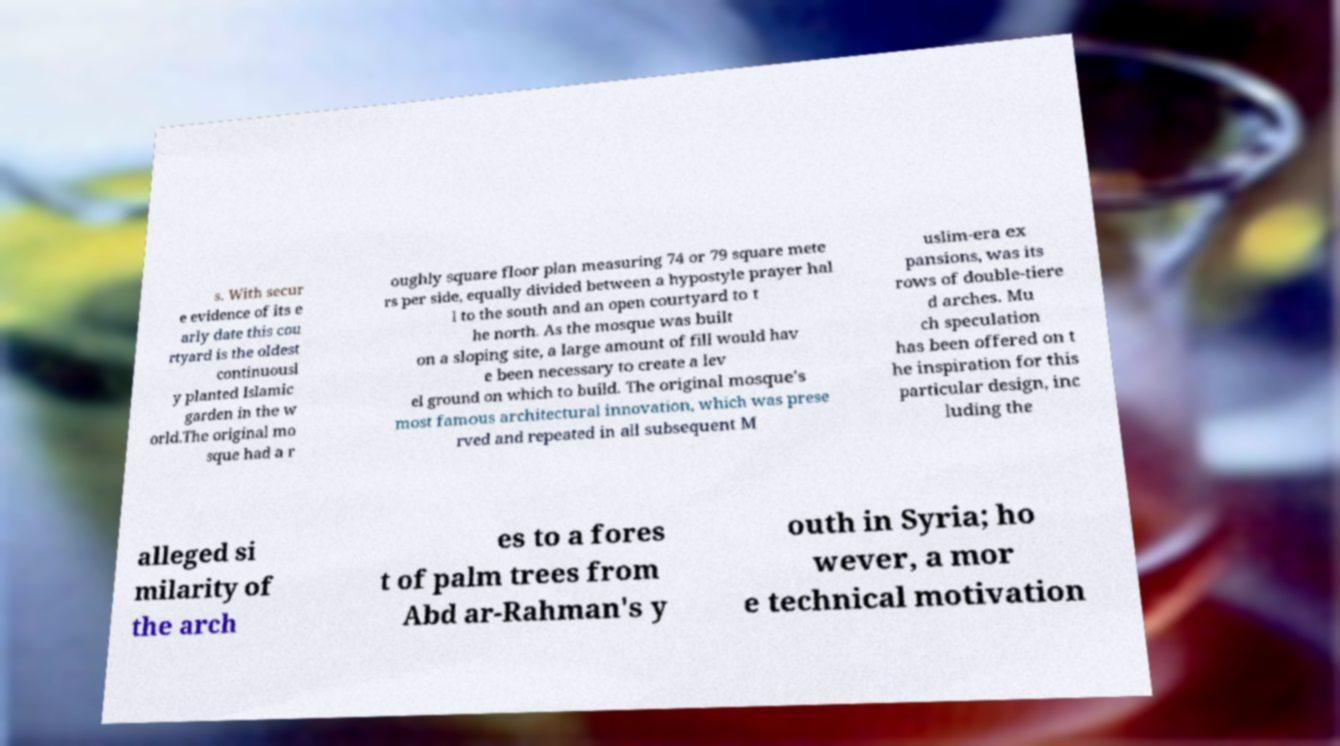Could you extract and type out the text from this image? s. With secur e evidence of its e arly date this cou rtyard is the oldest continuousl y planted Islamic garden in the w orld.The original mo sque had a r oughly square floor plan measuring 74 or 79 square mete rs per side, equally divided between a hypostyle prayer hal l to the south and an open courtyard to t he north. As the mosque was built on a sloping site, a large amount of fill would hav e been necessary to create a lev el ground on which to build. The original mosque's most famous architectural innovation, which was prese rved and repeated in all subsequent M uslim-era ex pansions, was its rows of double-tiere d arches. Mu ch speculation has been offered on t he inspiration for this particular design, inc luding the alleged si milarity of the arch es to a fores t of palm trees from Abd ar-Rahman's y outh in Syria; ho wever, a mor e technical motivation 